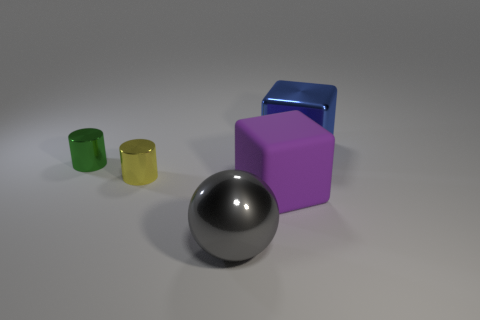Are there any other things that have the same shape as the large gray metal thing?
Offer a very short reply. No. What number of other big things are the same shape as the big purple rubber object?
Give a very brief answer. 1. What number of small gray cubes are there?
Your answer should be very brief. 0. What is the color of the small object in front of the tiny green shiny cylinder?
Ensure brevity in your answer.  Yellow. There is a large cube left of the big metallic object right of the big gray metal sphere; what is its color?
Offer a terse response. Purple. The matte cube that is the same size as the shiny cube is what color?
Your response must be concise. Purple. How many objects are both left of the large purple thing and in front of the green shiny thing?
Provide a succinct answer. 2. There is a thing that is behind the purple object and in front of the small green object; what material is it?
Ensure brevity in your answer.  Metal. Is the number of big gray objects behind the gray metal ball less than the number of tiny cylinders in front of the large matte cube?
Ensure brevity in your answer.  No. The yellow cylinder that is the same material as the tiny green cylinder is what size?
Your response must be concise. Small. 